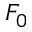<formula> <loc_0><loc_0><loc_500><loc_500>F _ { 0 }</formula> 